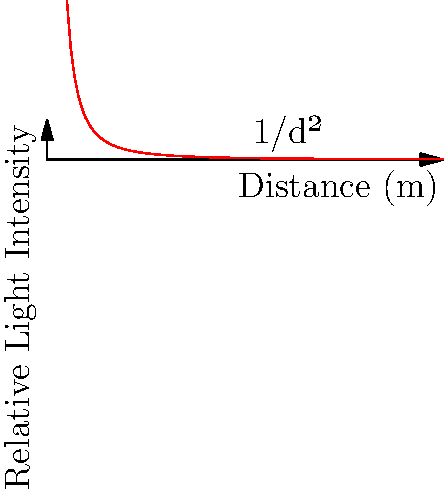As a paparazzi photographer, you're trying to capture a celebrity from a distance without being noticed. Your flash has a guide number of 60 (in meters) at ISO 100. If you're currently 5 meters away and getting perfect exposure, how far away can you move while still maintaining adequate exposure if you increase your ISO to 400? Let's approach this step-by-step:

1) The inverse square law states that light intensity is inversely proportional to the square of the distance from the source. This is represented by the equation:

   $$I \propto \frac{1}{d^2}$$

2) The guide number (GN) of a flash is related to distance (d) and f-number (f) by:

   $$GN = d \times f$$

3) At 5 meters with perfect exposure, we have:

   $$60 = 5 \times f$$
   $$f = 12$$

4) When we increase ISO from 100 to 400, we're quadrupling the light sensitivity. This means we can use 1/4 of the light for the same exposure.

5) Using the inverse square law, we can find the new distance:

   $$\frac{1}{5^2} \times \frac{1}{4} = \frac{1}{d^2}$$

6) Solving for d:

   $$d^2 = 5^2 \times 4 = 100$$
   $$d = 10$$

Therefore, you can move to 10 meters away while maintaining adequate exposure.
Answer: 10 meters 